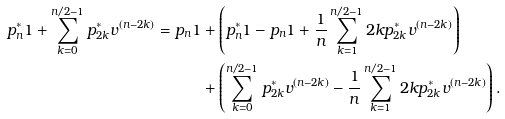<formula> <loc_0><loc_0><loc_500><loc_500>p _ { n } ^ { * } 1 + \sum _ { k = 0 } ^ { n / 2 - 1 } p _ { 2 k } ^ { * } v ^ { ( n - 2 k ) } = p _ { n } 1 & + \left ( p _ { n } ^ { * } 1 - p _ { n } 1 + \frac { 1 } { n } \sum _ { k = 1 } ^ { n / 2 - 1 } 2 k p _ { 2 k } ^ { * } v ^ { ( n - 2 k ) } \right ) \\ & + \left ( \sum _ { k = 0 } ^ { n / 2 - 1 } p _ { 2 k } ^ { * } v ^ { ( n - 2 k ) } - \frac { 1 } { n } \sum _ { k = 1 } ^ { n / 2 - 1 } 2 k p _ { 2 k } ^ { * } v ^ { ( n - 2 k ) } \right ) .</formula> 